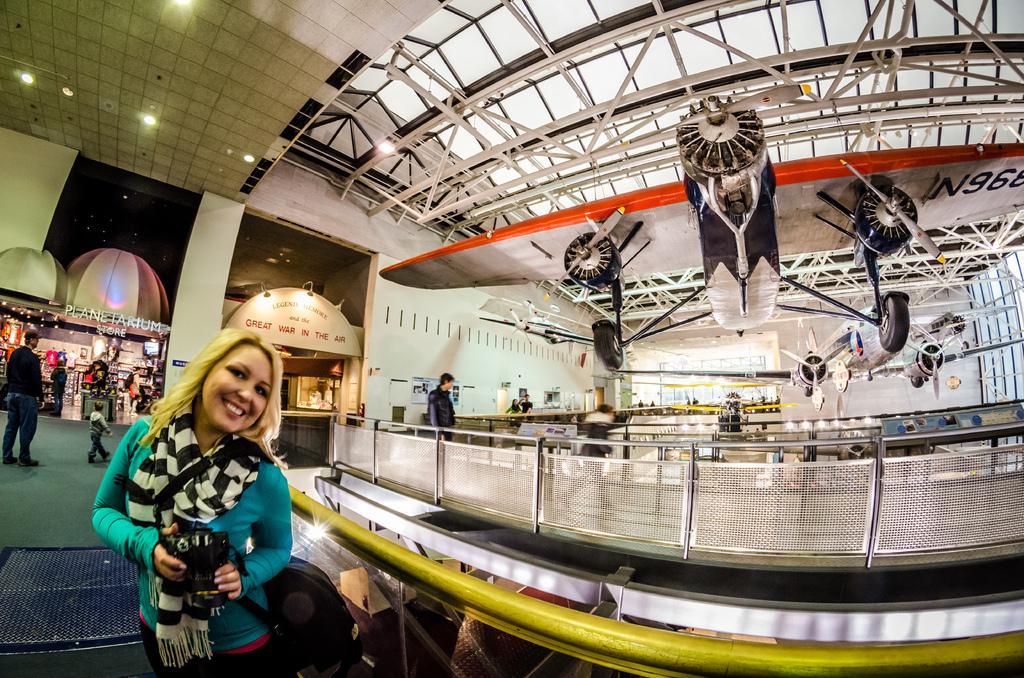Please provide a concise description of this image. There is one woman standing and holding a camera at the bottom of this image, and there are some other persons standing on the left side of this image, and there is a wall in the background. There is a model of a plane on the right side of this image. 